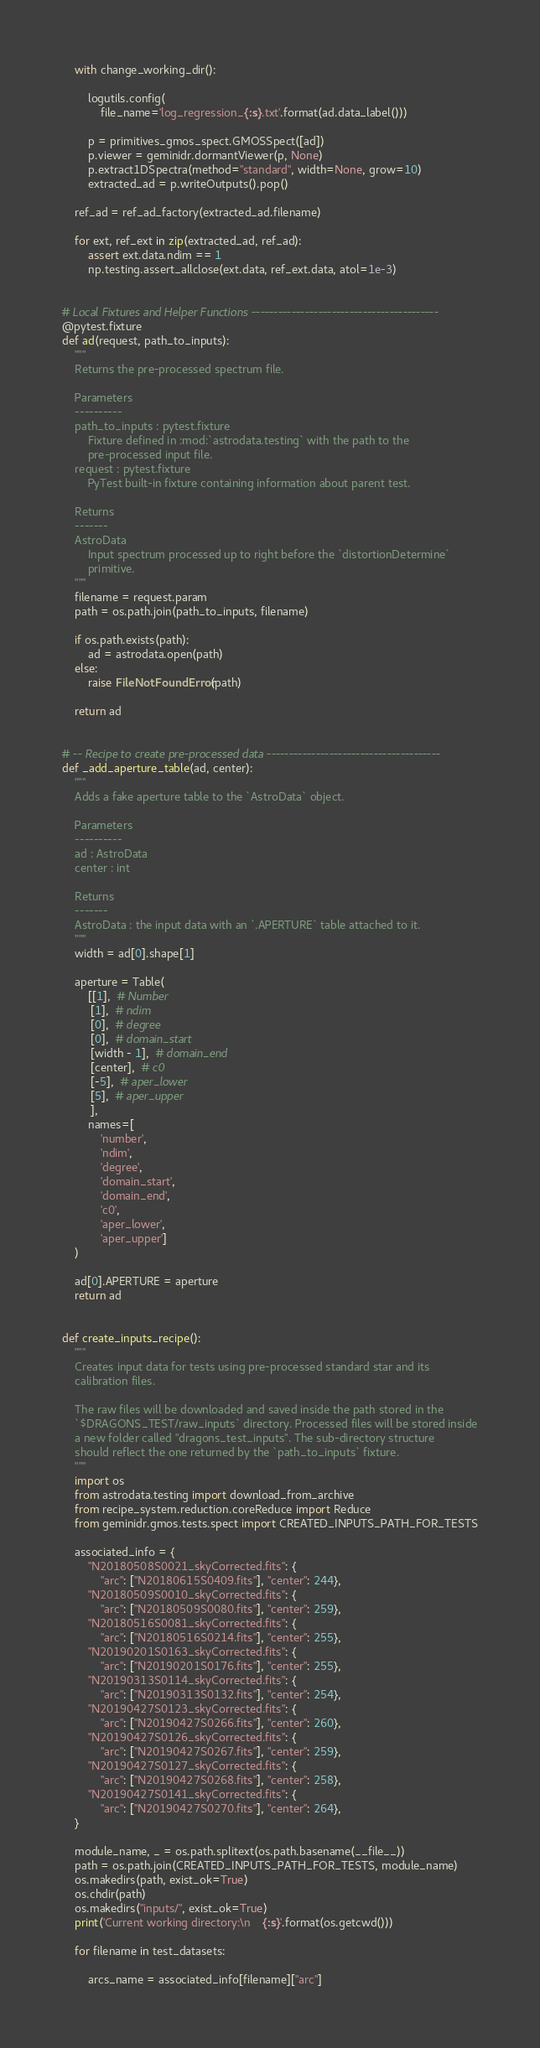Convert code to text. <code><loc_0><loc_0><loc_500><loc_500><_Python_>    with change_working_dir():

        logutils.config(
            file_name='log_regression_{:s}.txt'.format(ad.data_label()))

        p = primitives_gmos_spect.GMOSSpect([ad])
        p.viewer = geminidr.dormantViewer(p, None)
        p.extract1DSpectra(method="standard", width=None, grow=10)
        extracted_ad = p.writeOutputs().pop()

    ref_ad = ref_ad_factory(extracted_ad.filename)

    for ext, ref_ext in zip(extracted_ad, ref_ad):
        assert ext.data.ndim == 1
        np.testing.assert_allclose(ext.data, ref_ext.data, atol=1e-3)


# Local Fixtures and Helper Functions ------------------------------------------
@pytest.fixture
def ad(request, path_to_inputs):
    """
    Returns the pre-processed spectrum file.

    Parameters
    ----------
    path_to_inputs : pytest.fixture
        Fixture defined in :mod:`astrodata.testing` with the path to the
        pre-processed input file.
    request : pytest.fixture
        PyTest built-in fixture containing information about parent test.

    Returns
    -------
    AstroData
        Input spectrum processed up to right before the `distortionDetermine`
        primitive.
    """
    filename = request.param
    path = os.path.join(path_to_inputs, filename)

    if os.path.exists(path):
        ad = astrodata.open(path)
    else:
        raise FileNotFoundError(path)

    return ad


# -- Recipe to create pre-processed data ---------------------------------------
def _add_aperture_table(ad, center):
    """
    Adds a fake aperture table to the `AstroData` object.

    Parameters
    ----------
    ad : AstroData
    center : int

    Returns
    -------
    AstroData : the input data with an `.APERTURE` table attached to it.
    """
    width = ad[0].shape[1]

    aperture = Table(
        [[1],  # Number
         [1],  # ndim
         [0],  # degree
         [0],  # domain_start
         [width - 1],  # domain_end
         [center],  # c0
         [-5],  # aper_lower
         [5],  # aper_upper
         ],
        names=[
            'number',
            'ndim',
            'degree',
            'domain_start',
            'domain_end',
            'c0',
            'aper_lower',
            'aper_upper']
    )

    ad[0].APERTURE = aperture
    return ad


def create_inputs_recipe():
    """
    Creates input data for tests using pre-processed standard star and its
    calibration files.

    The raw files will be downloaded and saved inside the path stored in the
    `$DRAGONS_TEST/raw_inputs` directory. Processed files will be stored inside
    a new folder called "dragons_test_inputs". The sub-directory structure
    should reflect the one returned by the `path_to_inputs` fixture.
    """
    import os
    from astrodata.testing import download_from_archive
    from recipe_system.reduction.coreReduce import Reduce
    from geminidr.gmos.tests.spect import CREATED_INPUTS_PATH_FOR_TESTS

    associated_info = {
        "N20180508S0021_skyCorrected.fits": {
            "arc": ["N20180615S0409.fits"], "center": 244},
        "N20180509S0010_skyCorrected.fits": {
            "arc": ["N20180509S0080.fits"], "center": 259},
        "N20180516S0081_skyCorrected.fits": {
            "arc": ["N20180516S0214.fits"], "center": 255},
        "N20190201S0163_skyCorrected.fits": {
            "arc": ["N20190201S0176.fits"], "center": 255},
        "N20190313S0114_skyCorrected.fits": {
            "arc": ["N20190313S0132.fits"], "center": 254},
        "N20190427S0123_skyCorrected.fits": {
            "arc": ["N20190427S0266.fits"], "center": 260},
        "N20190427S0126_skyCorrected.fits": {
            "arc": ["N20190427S0267.fits"], "center": 259},
        "N20190427S0127_skyCorrected.fits": {
            "arc": ["N20190427S0268.fits"], "center": 258},
        "N20190427S0141_skyCorrected.fits": {
            "arc": ["N20190427S0270.fits"], "center": 264},
    }

    module_name, _ = os.path.splitext(os.path.basename(__file__))
    path = os.path.join(CREATED_INPUTS_PATH_FOR_TESTS, module_name)
    os.makedirs(path, exist_ok=True)
    os.chdir(path)
    os.makedirs("inputs/", exist_ok=True)
    print('Current working directory:\n    {:s}'.format(os.getcwd()))

    for filename in test_datasets:

        arcs_name = associated_info[filename]["arc"]</code> 